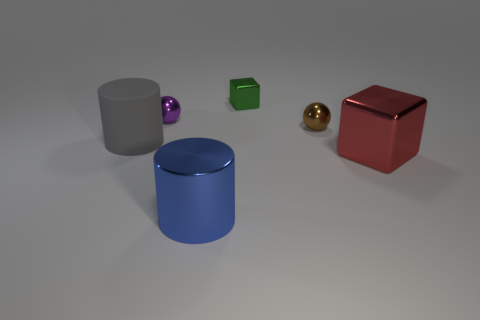Add 2 big brown rubber things. How many objects exist? 8 Subtract all cylinders. How many objects are left? 4 Add 4 tiny cyan rubber cubes. How many tiny cyan rubber cubes exist? 4 Subtract 0 gray balls. How many objects are left? 6 Subtract all tiny gray metal balls. Subtract all brown metal spheres. How many objects are left? 5 Add 1 large rubber cylinders. How many large rubber cylinders are left? 2 